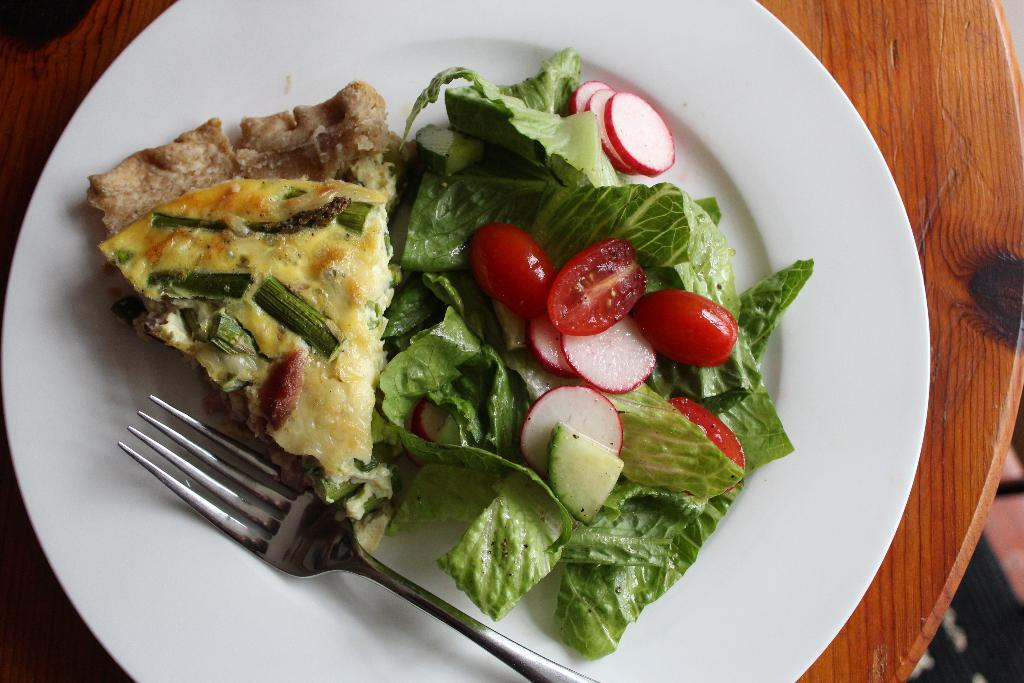What is on the plate in the image? There is food on a plate in the image. How is the food arranged on the plate? The food is in the center of the plate. What utensil is present on the plate? There is a fork on the plate. What type of veil can be seen covering the food in the image? There is no veil present in the image; the food is not covered. 